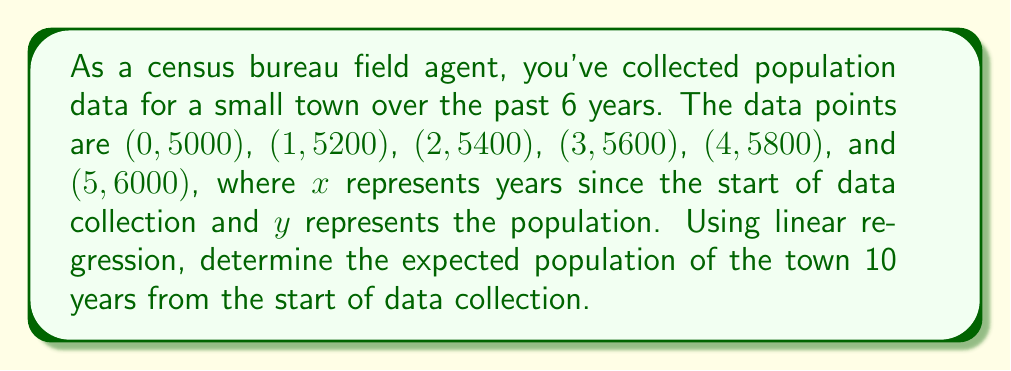What is the answer to this math problem? To solve this problem using linear regression, we'll follow these steps:

1) First, we need to find the equation of the line of best fit in the form $y = mx + b$, where $m$ is the slope and $b$ is the y-intercept.

2) To calculate the slope $m$, we use the formula:

   $m = \frac{n\sum xy - \sum x \sum y}{n\sum x^2 - (\sum x)^2}$

   Where $n$ is the number of data points (6 in this case).

3) Let's calculate the necessary sums:
   $\sum x = 0 + 1 + 2 + 3 + 4 + 5 = 15$
   $\sum y = 5000 + 5200 + 5400 + 5600 + 5800 + 6000 = 33000$
   $\sum xy = 0(5000) + 1(5200) + 2(5400) + 3(5600) + 4(5800) + 5(6000) = 93000$
   $\sum x^2 = 0^2 + 1^2 + 2^2 + 3^2 + 4^2 + 5^2 = 55$

4) Now we can calculate $m$:
   $m = \frac{6(93000) - 15(33000)}{6(55) - 15^2} = \frac{558000 - 495000}{330 - 225} = \frac{63000}{105} = 200$

5) To find $b$, we can use the formula $b = \bar{y} - m\bar{x}$, where $\bar{x}$ and $\bar{y}$ are the means of $x$ and $y$ respectively:
   $\bar{x} = \frac{15}{6} = 2.5$
   $\bar{y} = \frac{33000}{6} = 5500$
   $b = 5500 - 200(2.5) = 5000$

6) So our line of best fit is $y = 200x + 5000$

7) To find the expected population after 10 years, we substitute $x = 10$ into our equation:
   $y = 200(10) + 5000 = 2000 + 5000 = 7000$

Therefore, the expected population 10 years from the start of data collection is 7000.
Answer: 7000 